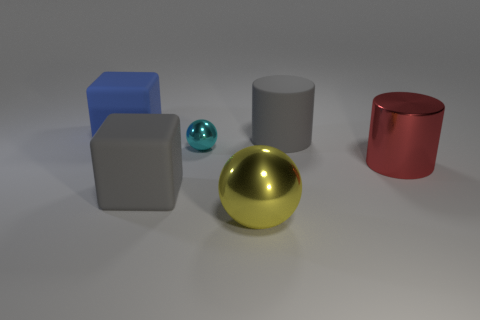Add 2 big cylinders. How many objects exist? 8 Subtract all cubes. How many objects are left? 4 Subtract 2 cylinders. How many cylinders are left? 0 Subtract all big gray cylinders. Subtract all small cyan balls. How many objects are left? 4 Add 3 blue matte things. How many blue matte things are left? 4 Add 2 purple spheres. How many purple spheres exist? 2 Subtract 1 red cylinders. How many objects are left? 5 Subtract all green balls. Subtract all purple cylinders. How many balls are left? 2 